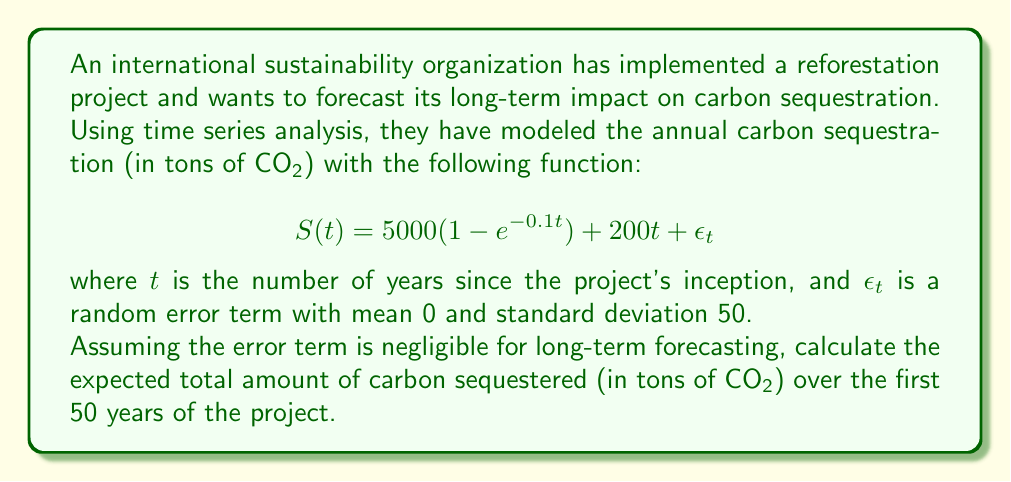Teach me how to tackle this problem. To solve this problem, we need to integrate the given function over the time period from 0 to 50 years, excluding the error term. Here's a step-by-step approach:

1) First, let's simplify the function by removing the error term:

   $$S(t) = 5000(1 - e^{-0.1t}) + 200t$$

2) To find the total amount of carbon sequestered over 50 years, we need to calculate the definite integral:

   $$\int_0^{50} S(t) dt = \int_0^{50} [5000(1 - e^{-0.1t}) + 200t] dt$$

3) Let's split this into two integrals:

   $$\int_0^{50} 5000(1 - e^{-0.1t}) dt + \int_0^{50} 200t dt$$

4) For the first integral:
   
   $$5000 \int_0^{50} (1 - e^{-0.1t}) dt = 5000 [t + 10e^{-0.1t}]_0^{50}$$
   $$= 5000 [(50 + 10e^{-5}) - (0 + 10)]$$
   $$= 5000 (50 + 10e^{-5} - 10)$$
   $$= 5000 (40 + 10e^{-5})$$

5) For the second integral:

   $$200 \int_0^{50} t dt = 200 [\frac{t^2}{2}]_0^{50}$$
   $$= 200 (\frac{50^2}{2} - 0)$$
   $$= 200 \cdot 1250 = 250,000$$

6) Adding the results from steps 4 and 5:

   $$5000 (40 + 10e^{-5}) + 250,000$$
   $$= 200,000 + 50,000e^{-5} + 250,000$$
   $$= 450,000 + 50,000e^{-5}$$

This is the total amount of carbon sequestered over 50 years in tons of CO2.
Answer: The expected total amount of carbon sequestered over the first 50 years of the project is $450,000 + 50,000e^{-5} \approx 450,337$ tons of CO2. 